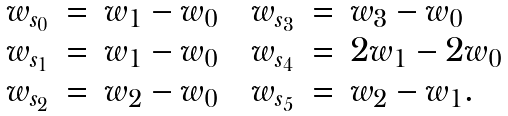<formula> <loc_0><loc_0><loc_500><loc_500>\begin{array} { r c l c r c l } w _ { s _ { 0 } } & = & w _ { 1 } - w _ { 0 } & & w _ { s _ { 3 } } & = & w _ { 3 } - w _ { 0 } \\ w _ { s _ { 1 } } & = & w _ { 1 } - w _ { 0 } & & w _ { s _ { 4 } } & = & 2 w _ { 1 } - 2 w _ { 0 } \\ w _ { s _ { 2 } } & = & w _ { 2 } - w _ { 0 } & & w _ { s _ { 5 } } & = & w _ { 2 } - w _ { 1 } . \end{array}</formula> 